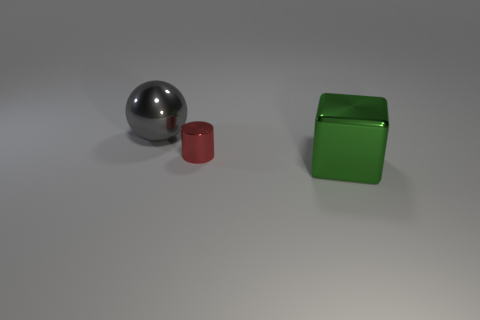Add 1 large gray spheres. How many objects exist? 4 Subtract all cylinders. How many objects are left? 2 Subtract 1 red cylinders. How many objects are left? 2 Subtract all metal objects. Subtract all yellow things. How many objects are left? 0 Add 1 tiny cylinders. How many tiny cylinders are left? 2 Add 1 big blue metallic cylinders. How many big blue metallic cylinders exist? 1 